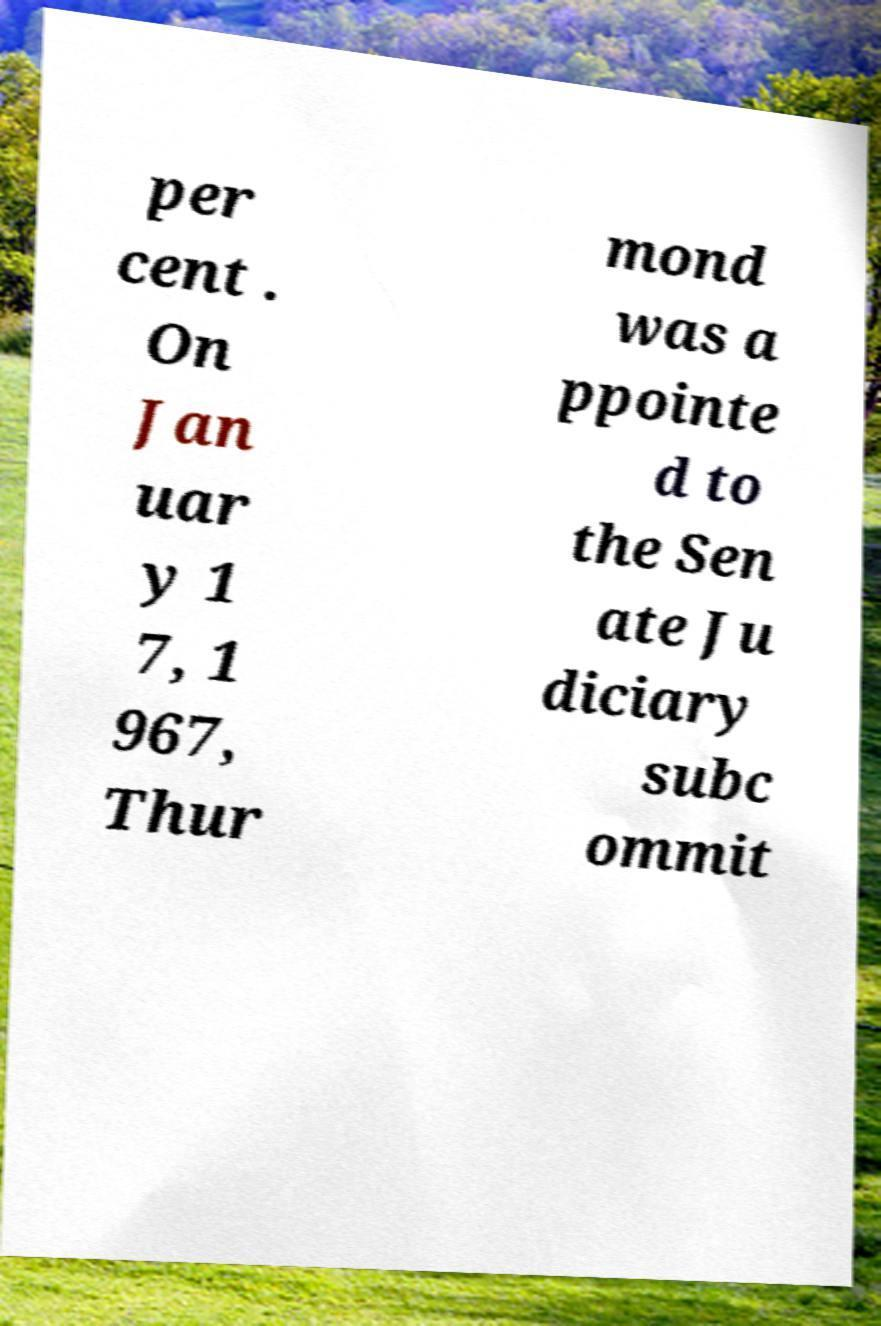Please read and relay the text visible in this image. What does it say? per cent . On Jan uar y 1 7, 1 967, Thur mond was a ppointe d to the Sen ate Ju diciary subc ommit 